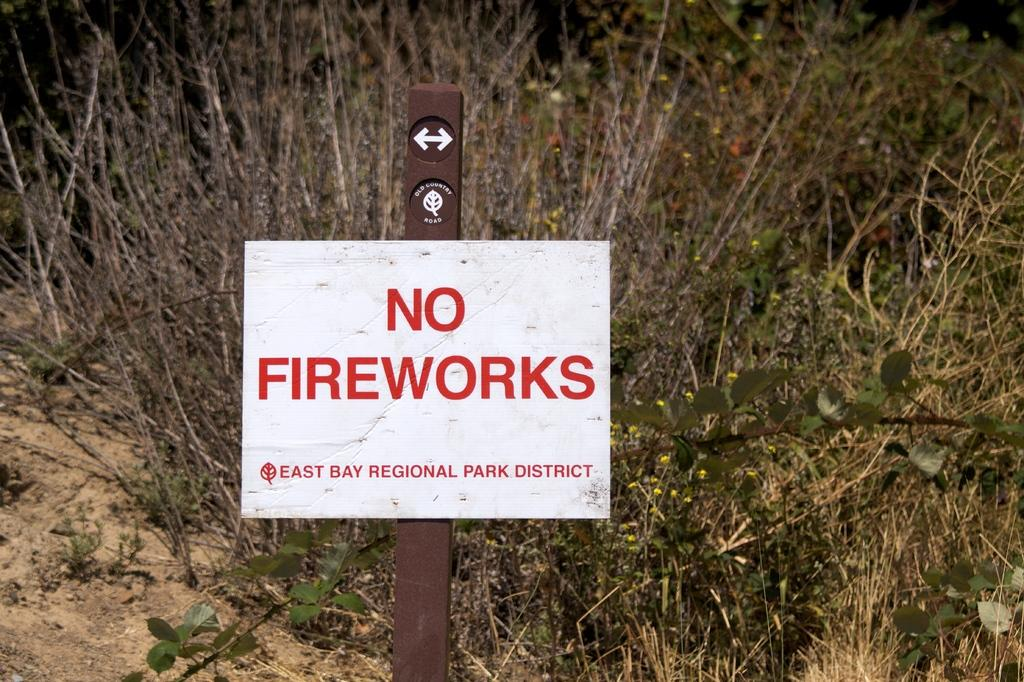What is the main object in the image? There is a sign board in the image. What does the sign board communicate? The sign board prohibits fireworks. What type of natural environment can be seen in the background of the image? There are plants and grass visible in the background of the image. Where is the hammer placed in the image? There is no hammer present in the image. What type of vase can be seen in the image? There is no vase present in the image. 